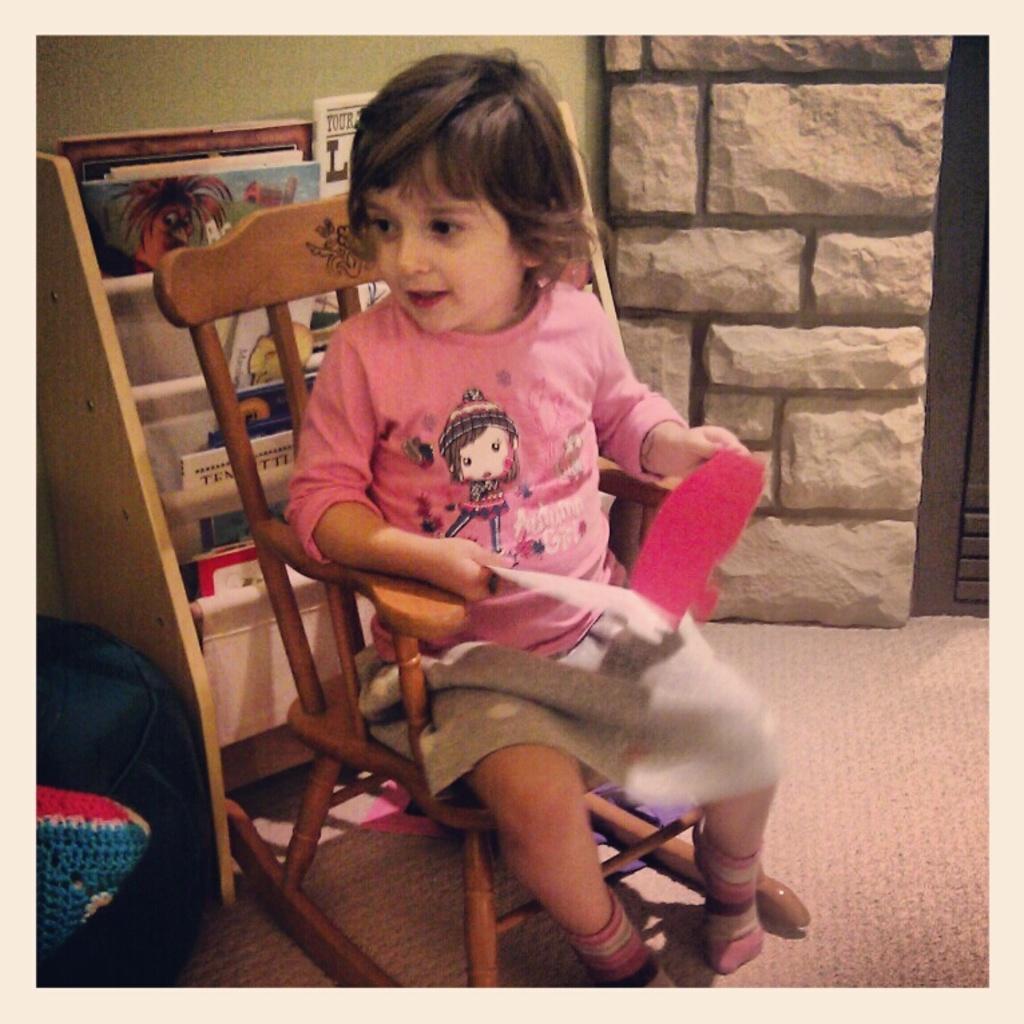Could you give a brief overview of what you see in this image? In the center we can see one person sitting on the chair. And coming to the background we can see wall and shelf with full of books and backpack. 